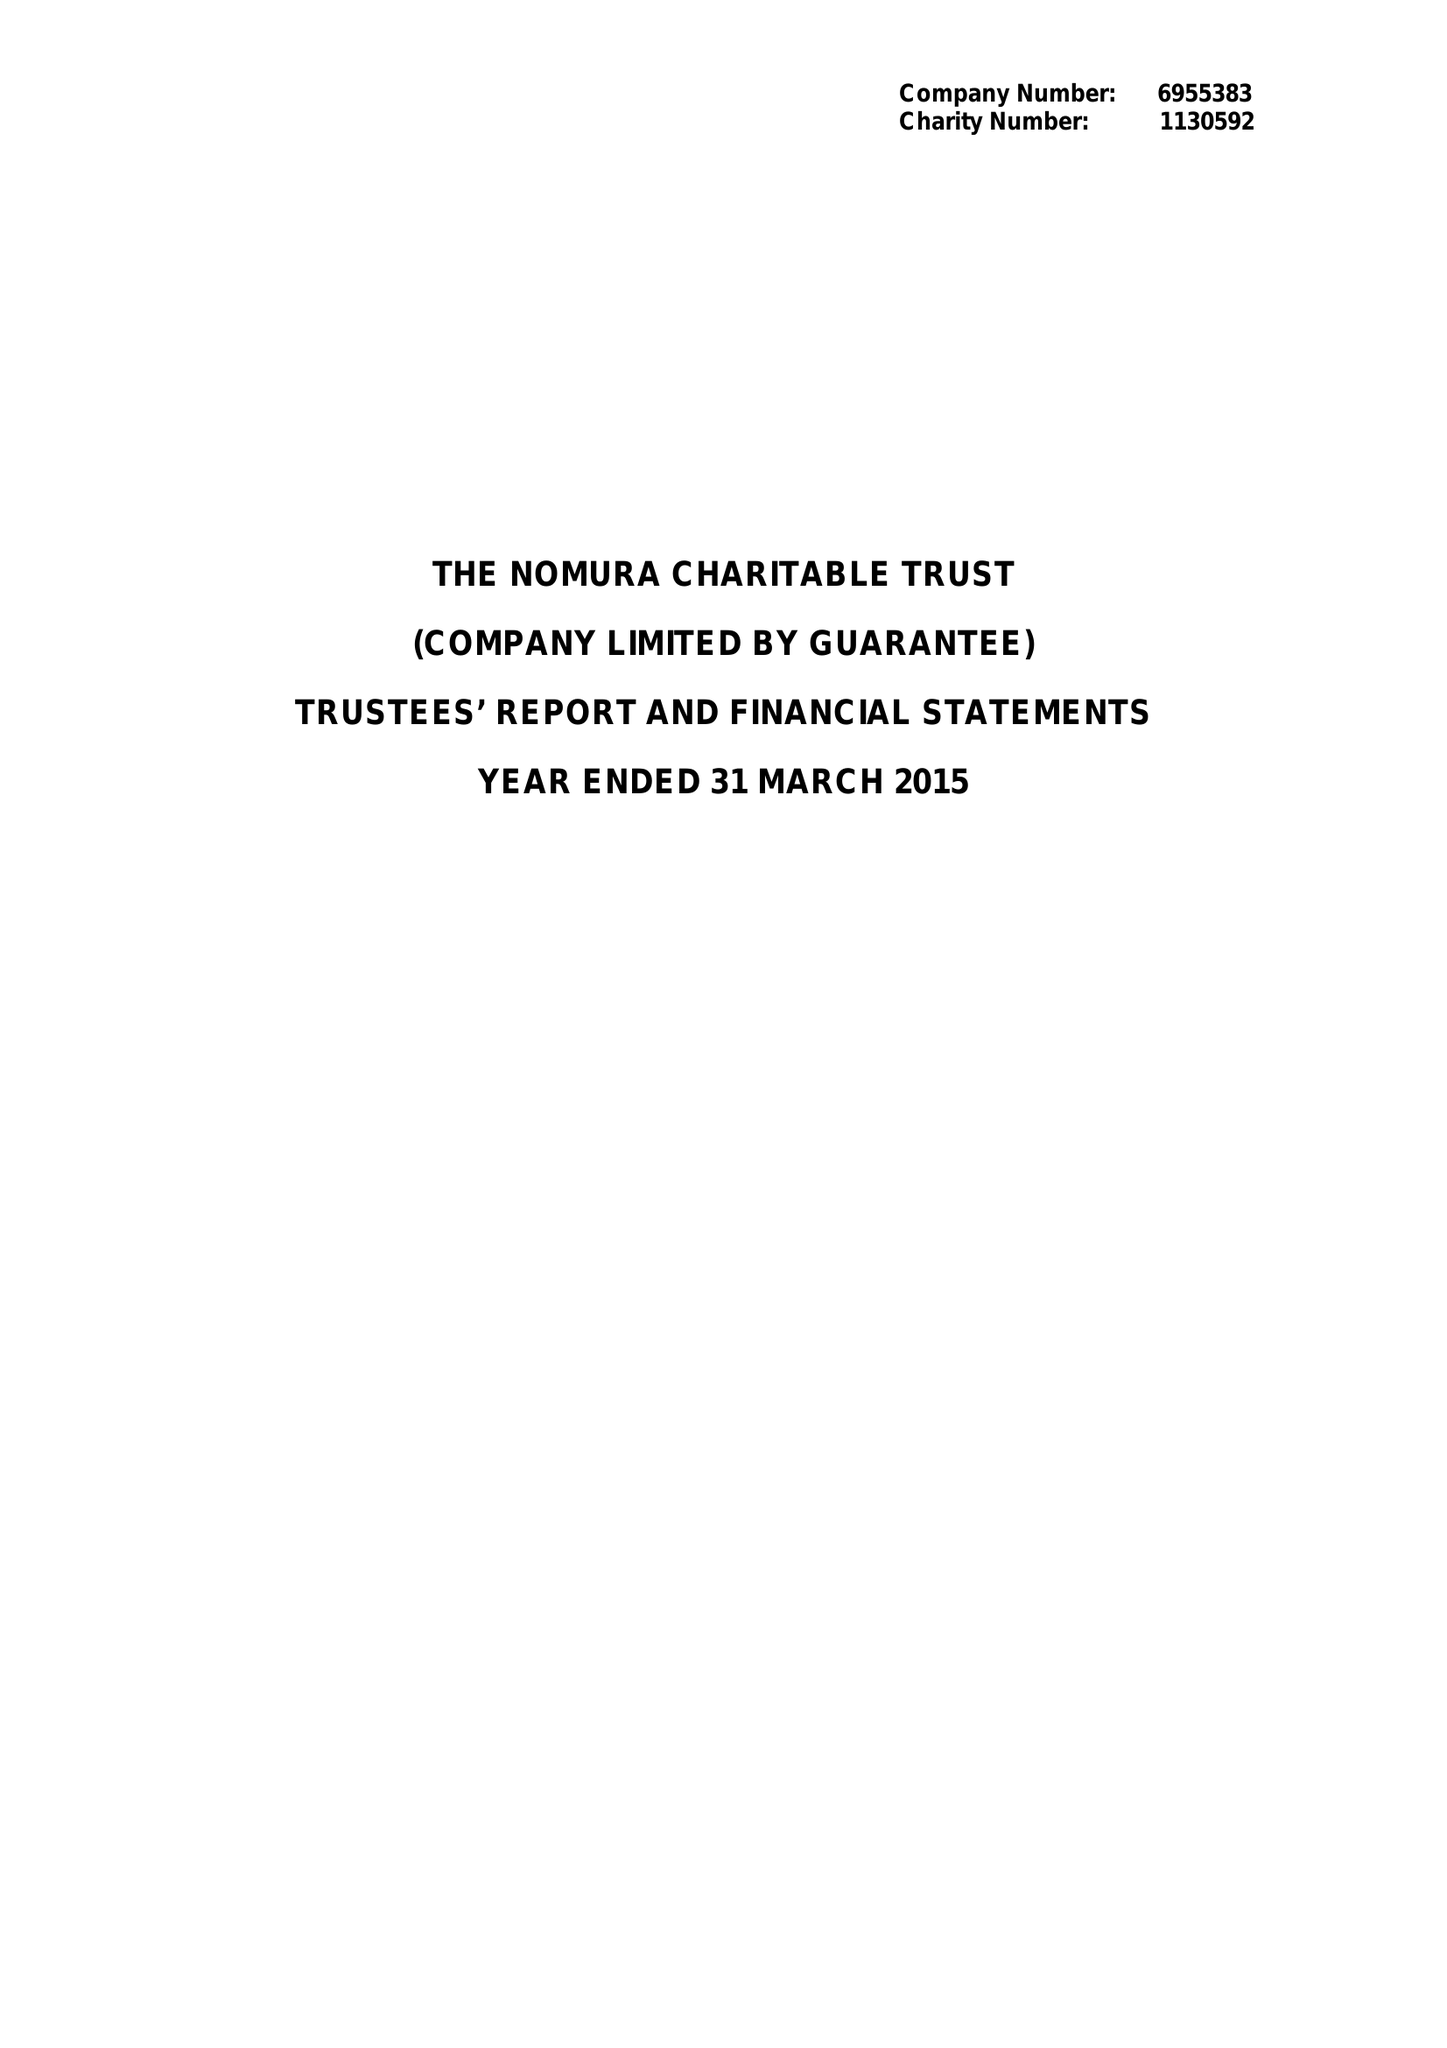What is the value for the address__post_town?
Answer the question using a single word or phrase. LONDON 